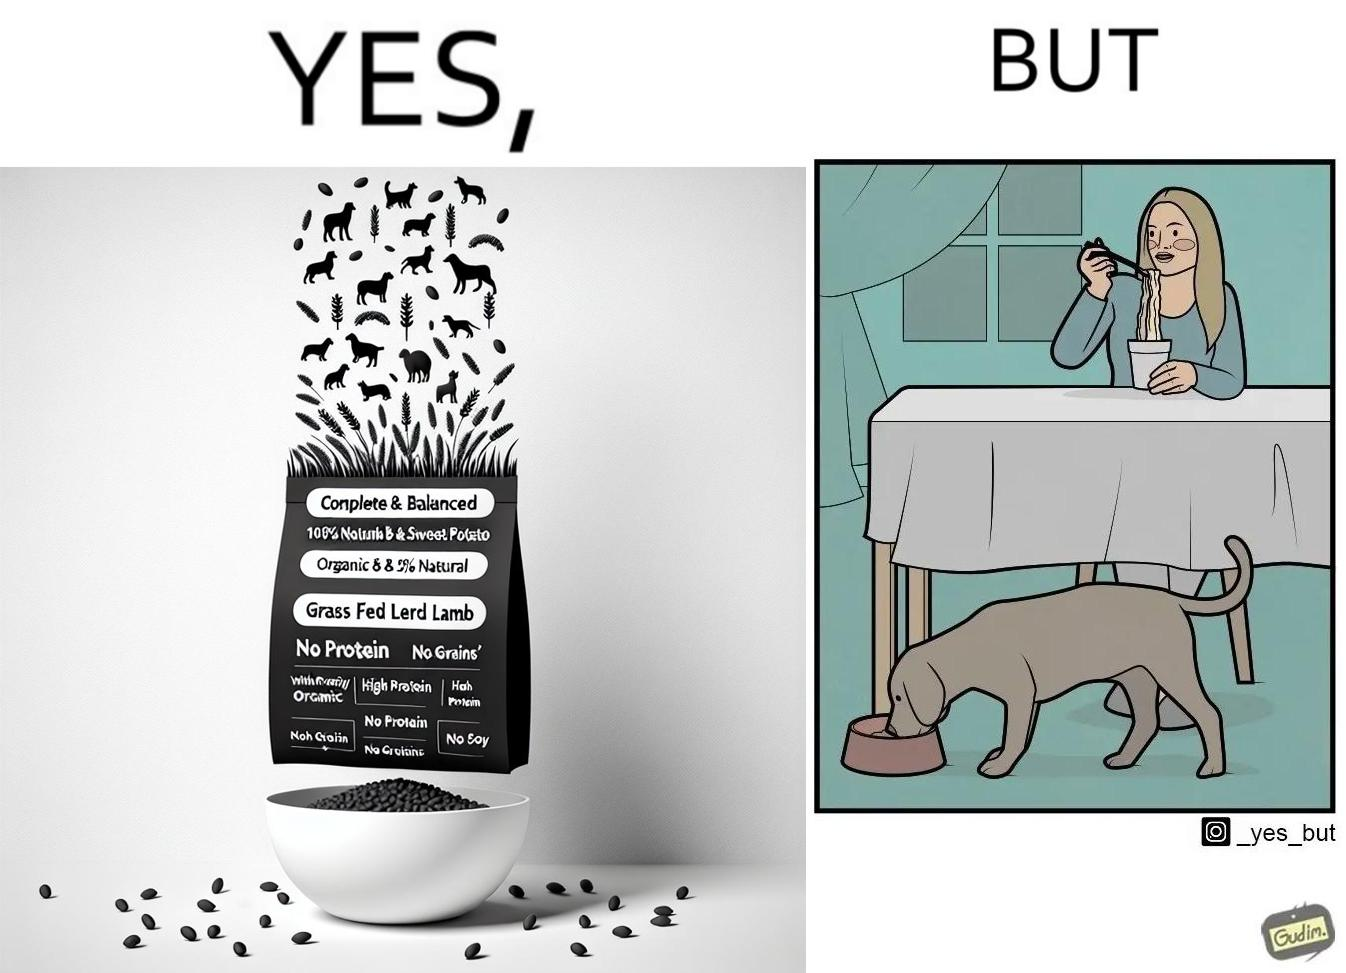What is the satirical meaning behind this image? The image is funny because while the food for the dog that the woman pours is well balanced, the food that she herself is eating is bad for her health. 